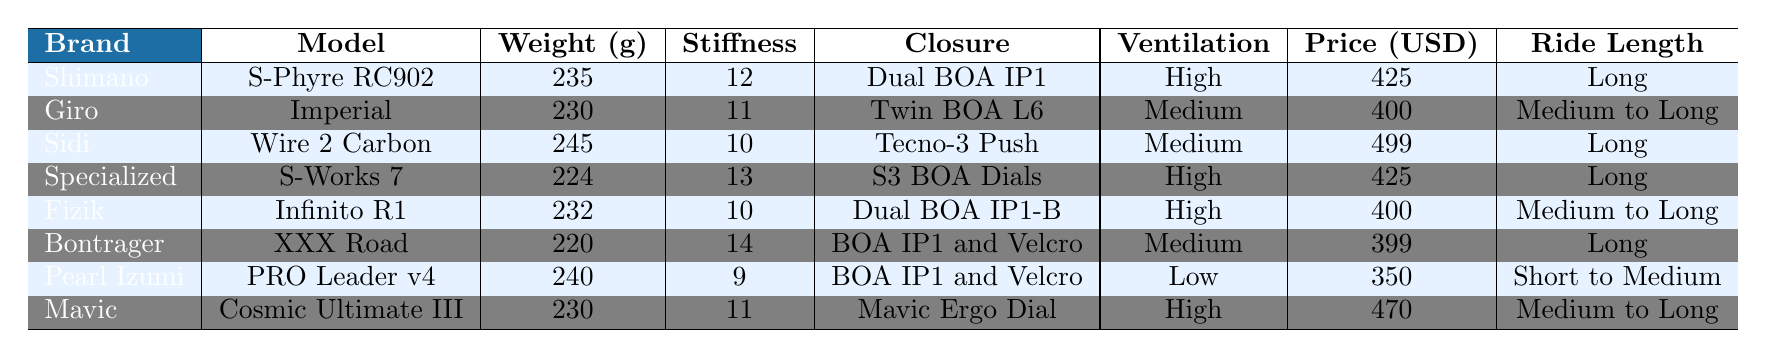What is the lightest cycling shoe model listed? The lightest weight in the table is 220 grams for the Bontrager XXX Road model.
Answer: 220 grams Which model has the highest stiffness rating? The model with the highest stiffness rating is the Bontrager XXX Road with a rating of 14.
Answer: 14 Is there a model that has both a high ventilation level and high stiffness rating? Yes, both the Shimano S-Phyre RC902 and Specialized S-Works 7 have high ventilation levels, and their stiffness ratings are 12 and 13, respectively.
Answer: Yes What is the total weight of the heaviest and lightest cycling shoes? The heaviest shoe weighs 245 grams (Sidi Wire 2 Carbon), and the lightest weighs 220 grams (Bontrager XXX Road). The total weight is 245 + 220 = 465 grams.
Answer: 465 grams What percentage of models have a stiffness rating of 10 or less? There are 3 models (Sidi Wire 2 Carbon, Fizik Infinito R1, and Pearl Izumi PRO Leader v4) with a stiffness rating of 10 or less out of 8 total models. The percentage is (3/8) * 100 = 37.5%.
Answer: 37.5% Which brand has the most expensive model, and what is its price? The most expensive model listed is the Sidi Wire 2 Carbon at a price of 499 USD.
Answer: 499 USD Are there any models that are recommended for long rides with low ventilation? No, all models recommended for long rides have either high or medium ventilation levels.
Answer: No Which closure system is used by the most models? The BOA IP1 and Velcro closure system is used by 2 models (Bontrager XXX Road and Pearl Izumi PRO Leader v4), which is the most common.
Answer: BOA IP1 and Velcro How many brands have models priced below 400 USD? There are 3 brands with models priced below 400 USD: Bontrager, Pearl Izumi, and Giro.
Answer: 3 What is the average weight of all the shoe models listed? The total weight of all models is 235 + 230 + 245 + 224 + 232 + 220 + 240 + 230 = 1,856 grams. Divided by 8 models, the average weight is 1,856 / 8 = 232 grams.
Answer: 232 grams 